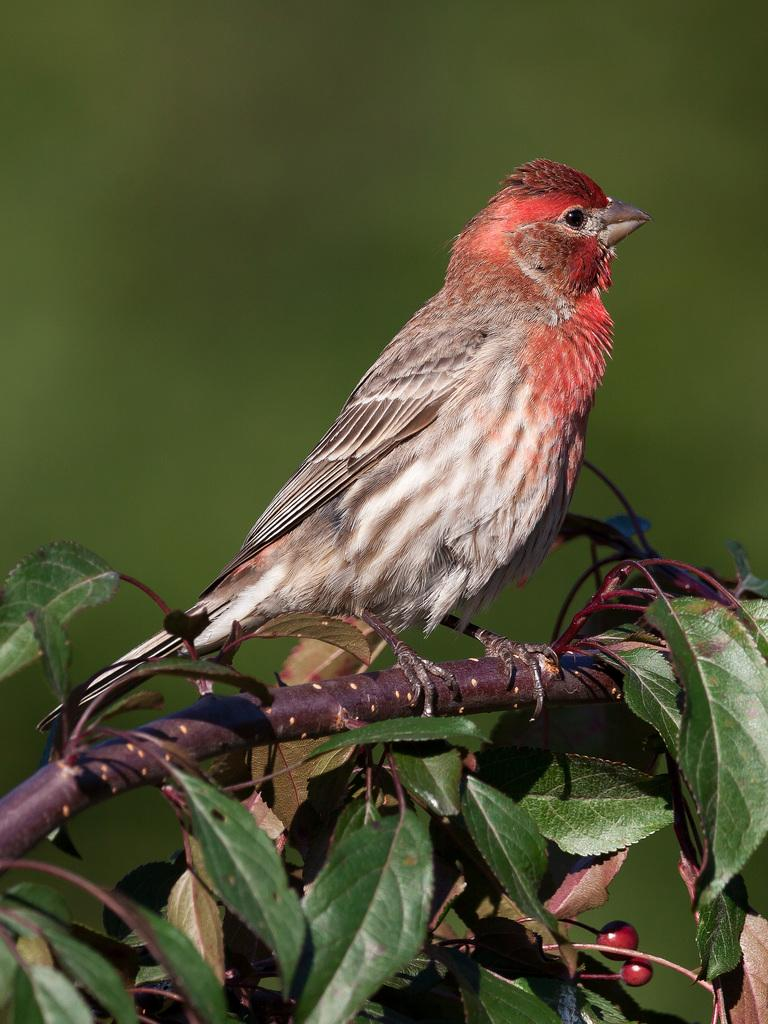What type of animal can be seen in the image? There is a bird in the image. Where is the bird located in the image? The bird is standing on a stem. What is the stem supporting in the image? The stem has leaves and fruits. What color is predominant in the background of the image? The background of the image is green. Can you hear the bird singing in the image? The image is a still picture, so it does not capture any sounds, including the bird singing. 